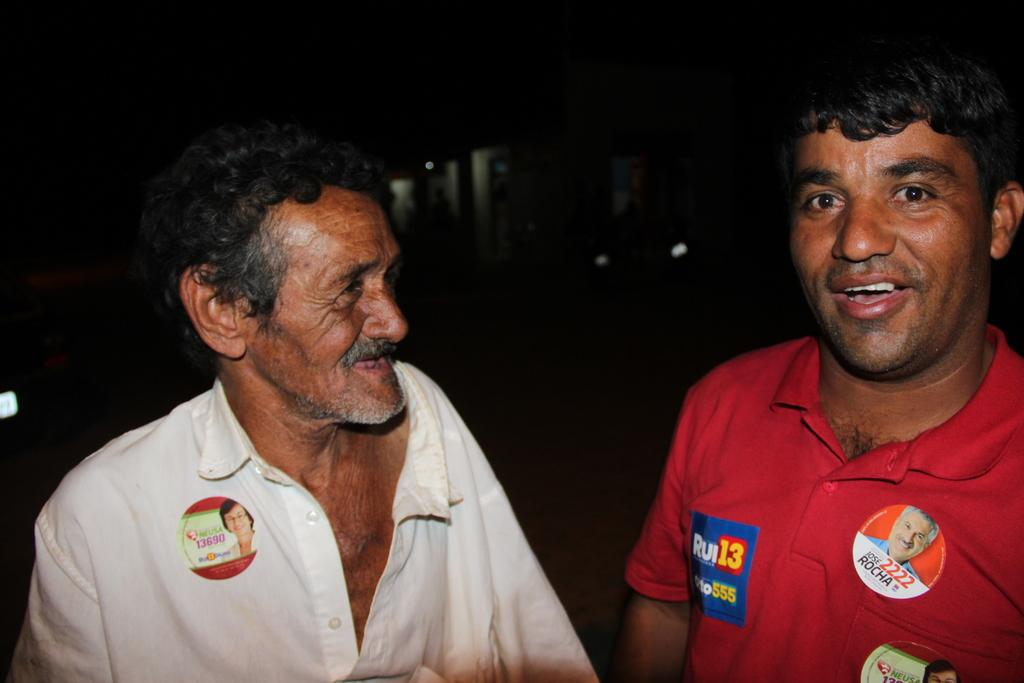Who or what is present in the image? There are people in the image. What are the people doing or expressing in the image? The people are smiling. What degree of temperature is the ghost experiencing in the image? There is no ghost present in the image, so it is not possible to determine the temperature it might be experiencing. 